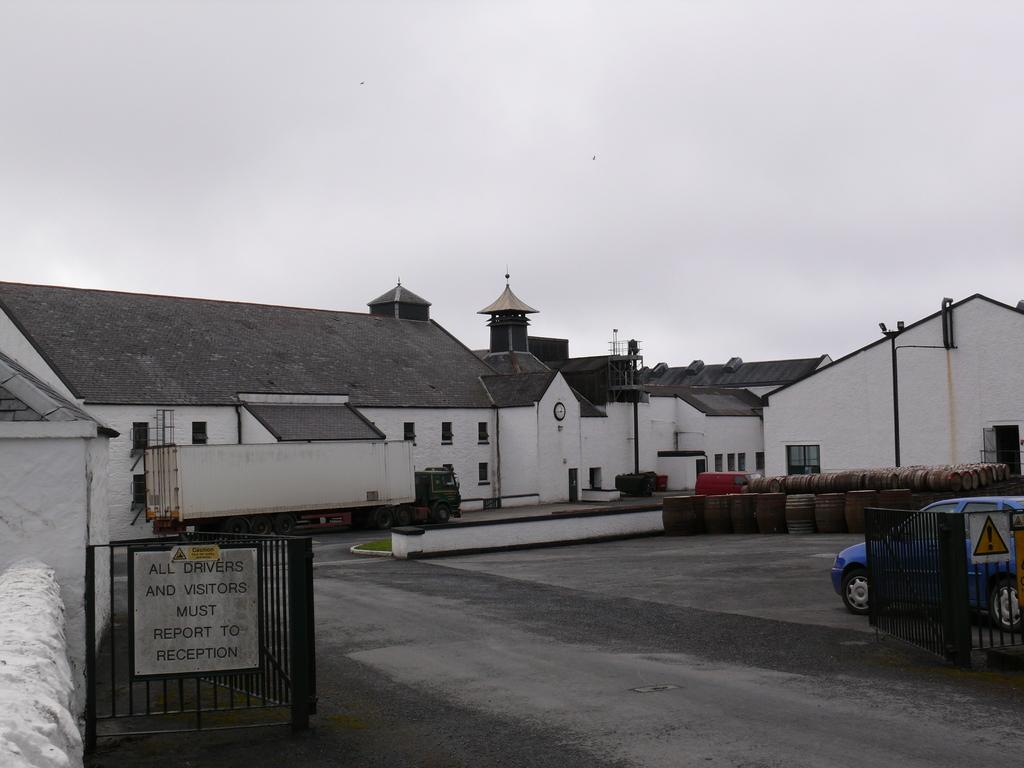What can be seen on the road in the image? There are vehicles on the road in the image. What type of structures are visible in the image? There are houses visible in the image. What objects are present in the image that are not vehicles or houses? There are drums present in the image. What type of coastline can be seen in the image? There is no coastline present in the image; it features vehicles on the road and houses. What industry is depicted in the image? There is no specific industry depicted in the image; it shows vehicles, houses, and drums. 